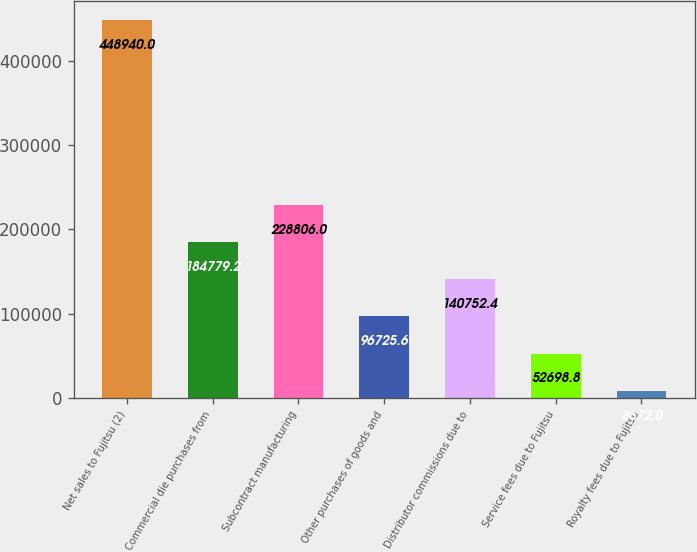Convert chart. <chart><loc_0><loc_0><loc_500><loc_500><bar_chart><fcel>Net sales to Fujitsu (2)<fcel>Commercial die purchases from<fcel>Subcontract manufacturing<fcel>Other purchases of goods and<fcel>Distributor commissions due to<fcel>Service fees due to Fujitsu<fcel>Royalty fees due to Fujitsu<nl><fcel>448940<fcel>184779<fcel>228806<fcel>96725.6<fcel>140752<fcel>52698.8<fcel>8672<nl></chart> 